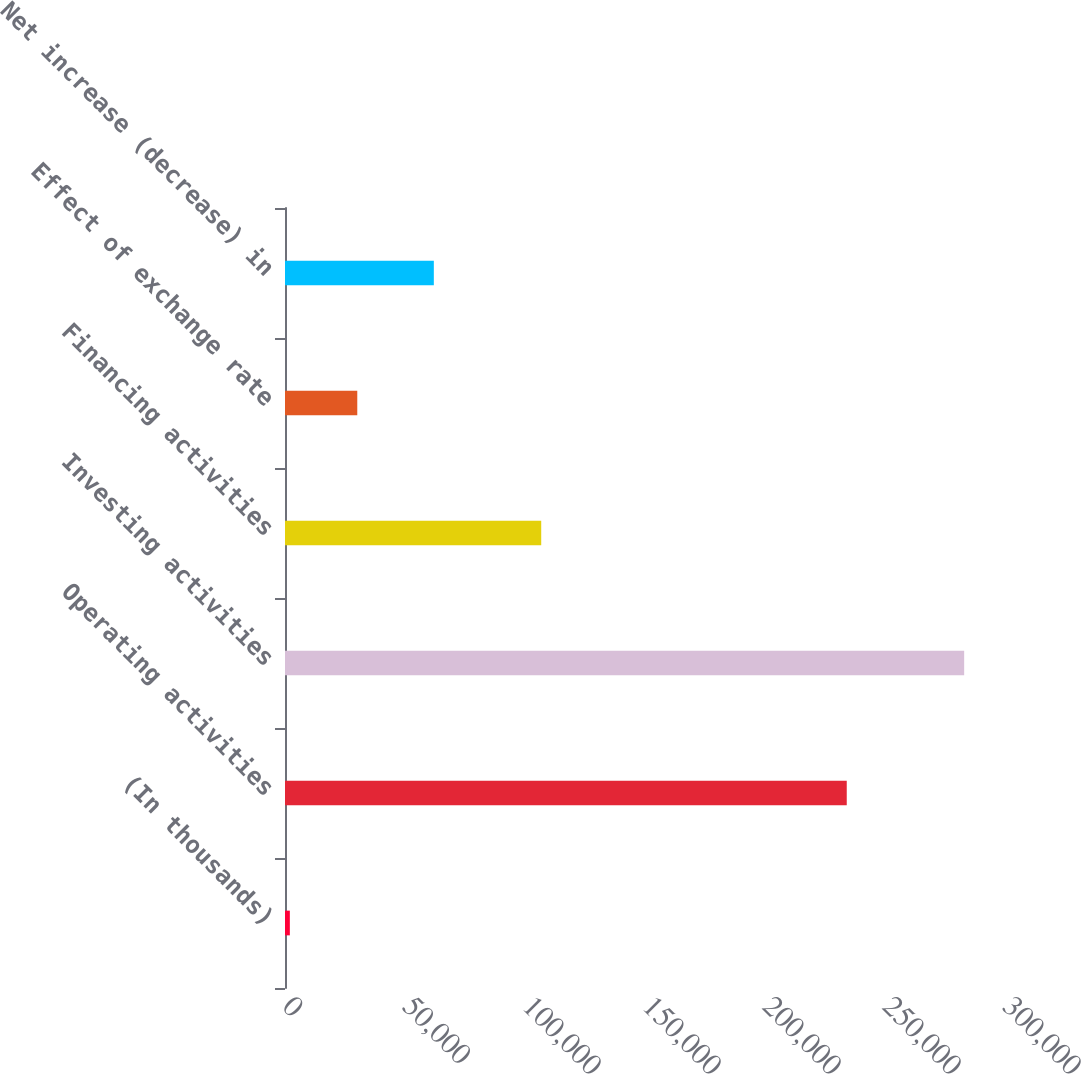Convert chart. <chart><loc_0><loc_0><loc_500><loc_500><bar_chart><fcel>(In thousands)<fcel>Operating activities<fcel>Investing activities<fcel>Financing activities<fcel>Effect of exchange rate<fcel>Net increase (decrease) in<nl><fcel>2017<fcel>234063<fcel>282987<fcel>106759<fcel>30114<fcel>62013<nl></chart> 